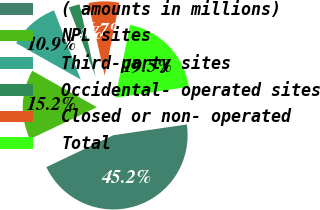Convert chart to OTSL. <chart><loc_0><loc_0><loc_500><loc_500><pie_chart><fcel>( amounts in millions)<fcel>NPL sites<fcel>Third-party sites<fcel>Occidental- operated sites<fcel>Closed or non- operated<fcel>Total<nl><fcel>45.24%<fcel>15.24%<fcel>10.95%<fcel>2.38%<fcel>6.67%<fcel>19.52%<nl></chart> 